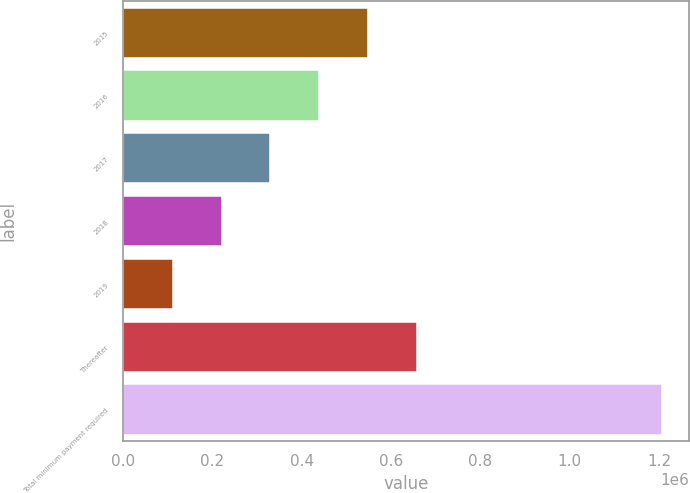Convert chart. <chart><loc_0><loc_0><loc_500><loc_500><bar_chart><fcel>2015<fcel>2016<fcel>2017<fcel>2018<fcel>2019<fcel>Thereafter<fcel>Total minimum payment required<nl><fcel>549322<fcel>439695<fcel>330068<fcel>220440<fcel>110813<fcel>658950<fcel>1.20709e+06<nl></chart> 